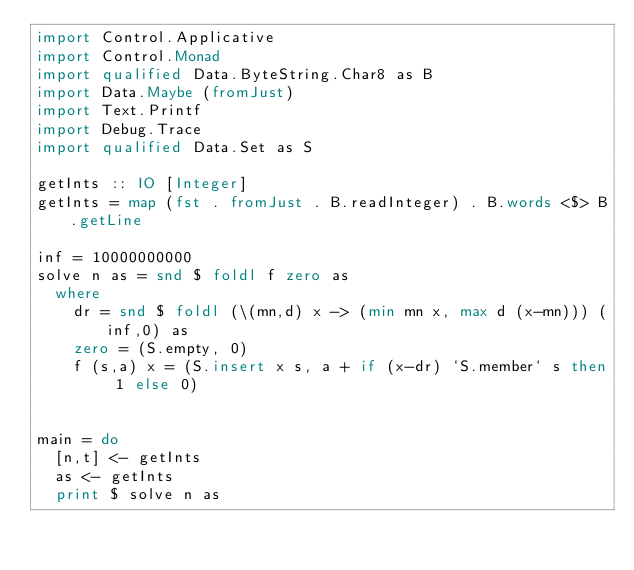Convert code to text. <code><loc_0><loc_0><loc_500><loc_500><_Haskell_>import Control.Applicative
import Control.Monad
import qualified Data.ByteString.Char8 as B
import Data.Maybe (fromJust)
import Text.Printf
import Debug.Trace
import qualified Data.Set as S

getInts :: IO [Integer]
getInts = map (fst . fromJust . B.readInteger) . B.words <$> B.getLine

inf = 10000000000
solve n as = snd $ foldl f zero as
  where
    dr = snd $ foldl (\(mn,d) x -> (min mn x, max d (x-mn))) (inf,0) as
    zero = (S.empty, 0)
    f (s,a) x = (S.insert x s, a + if (x-dr) `S.member` s then 1 else 0)


main = do
  [n,t] <- getInts
  as <- getInts
  print $ solve n as
</code> 